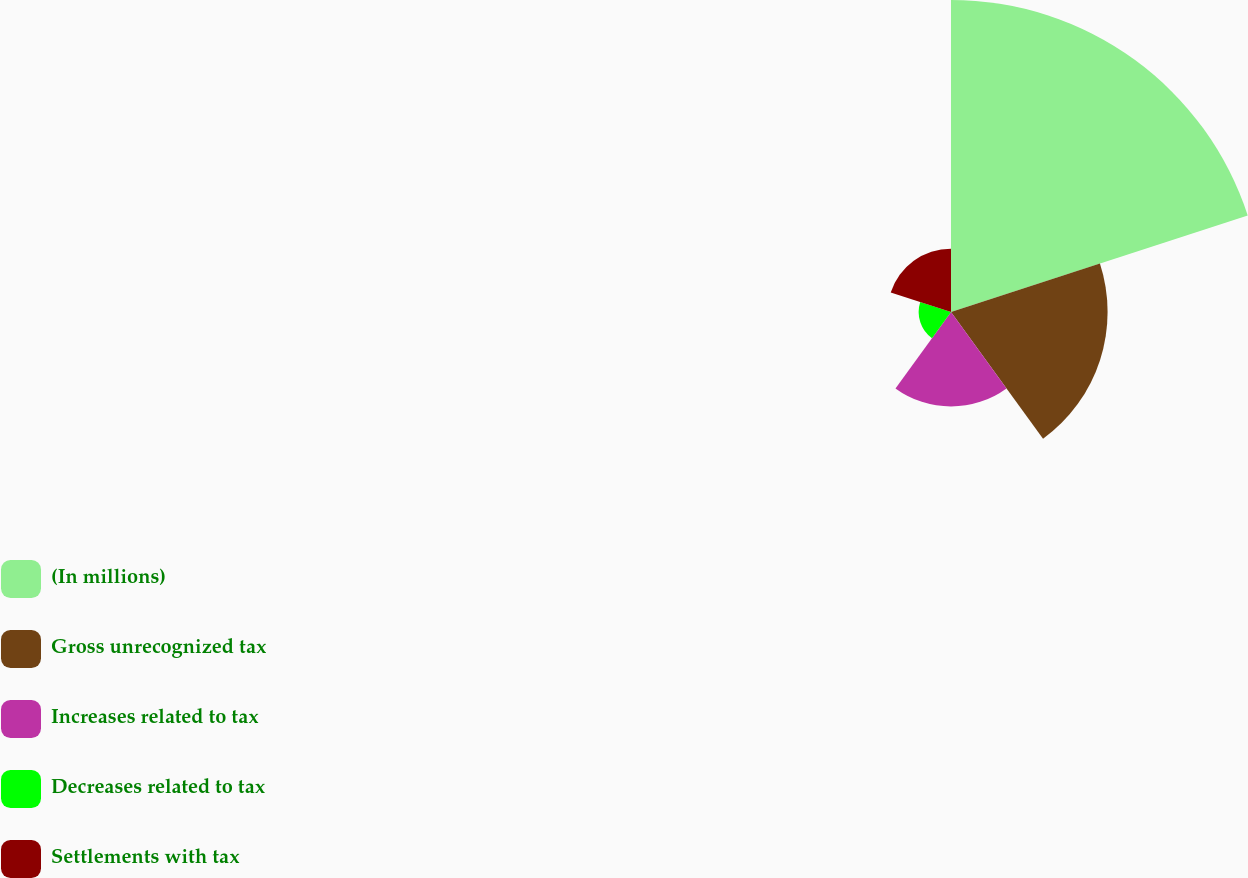Convert chart. <chart><loc_0><loc_0><loc_500><loc_500><pie_chart><fcel>(In millions)<fcel>Gross unrecognized tax<fcel>Increases related to tax<fcel>Decreases related to tax<fcel>Settlements with tax<nl><fcel>47.36%<fcel>23.77%<fcel>14.34%<fcel>4.91%<fcel>9.62%<nl></chart> 